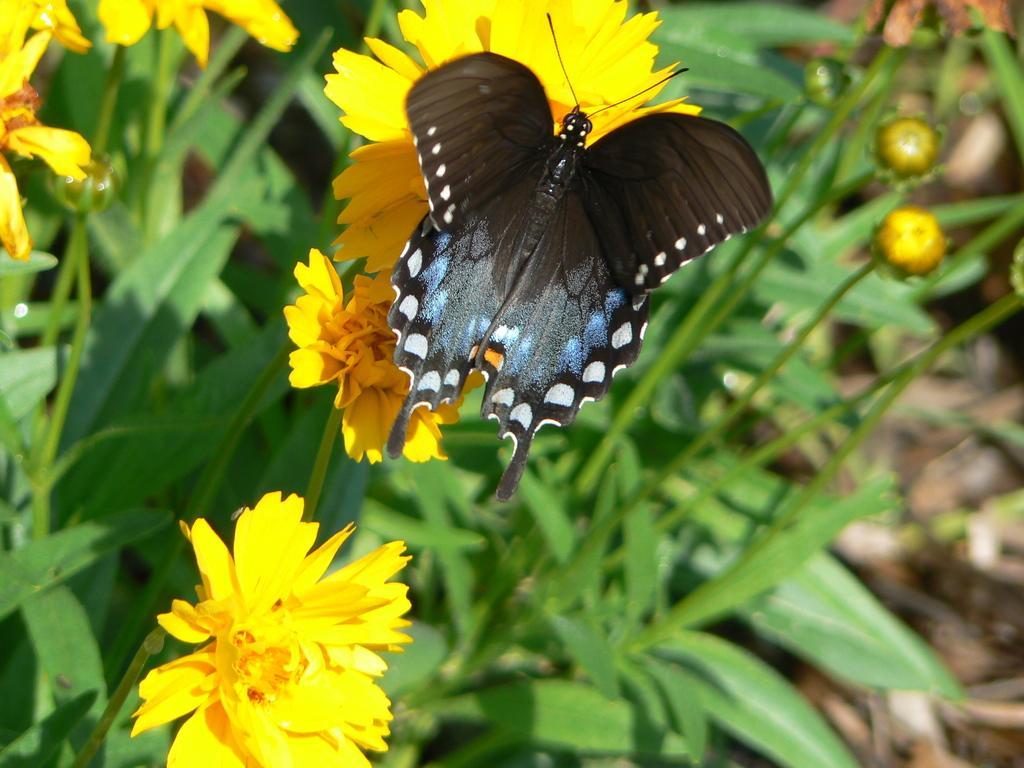Describe this image in one or two sentences. In this image I can see a butterfly which is black, white and blue in color on a flower. I can see few yellow colored flowers to the plants which are green in color. 